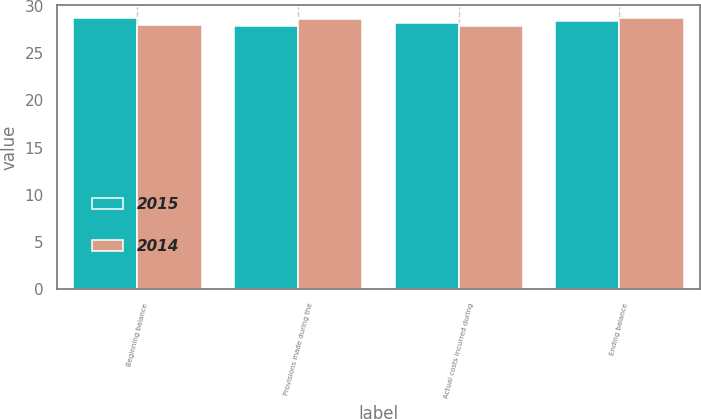Convert chart to OTSL. <chart><loc_0><loc_0><loc_500><loc_500><stacked_bar_chart><ecel><fcel>Beginning balance<fcel>Provisions made during the<fcel>Actual costs incurred during<fcel>Ending balance<nl><fcel>2015<fcel>28.7<fcel>27.9<fcel>28.2<fcel>28.4<nl><fcel>2014<fcel>28<fcel>28.6<fcel>27.9<fcel>28.7<nl></chart> 